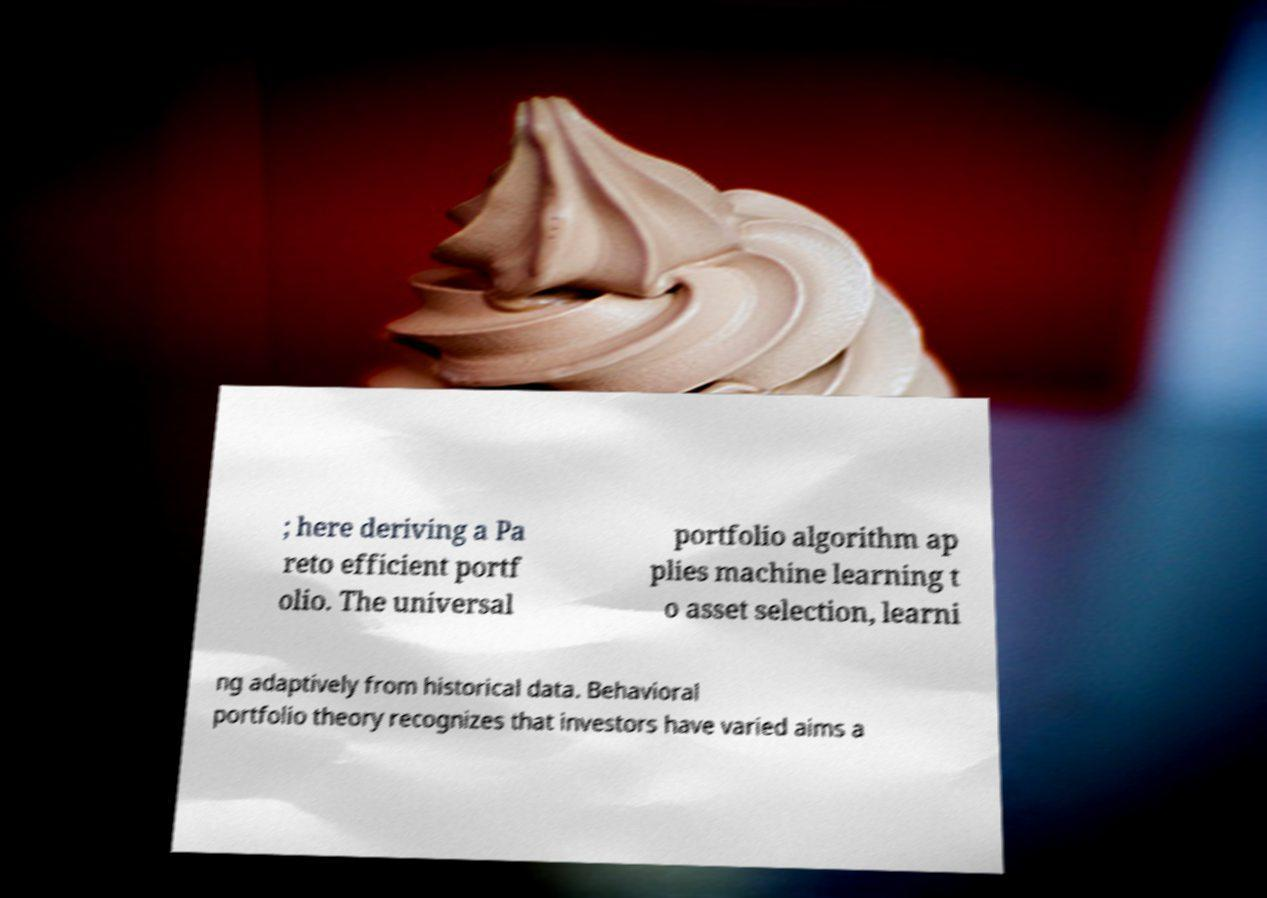Could you assist in decoding the text presented in this image and type it out clearly? ; here deriving a Pa reto efficient portf olio. The universal portfolio algorithm ap plies machine learning t o asset selection, learni ng adaptively from historical data. Behavioral portfolio theory recognizes that investors have varied aims a 